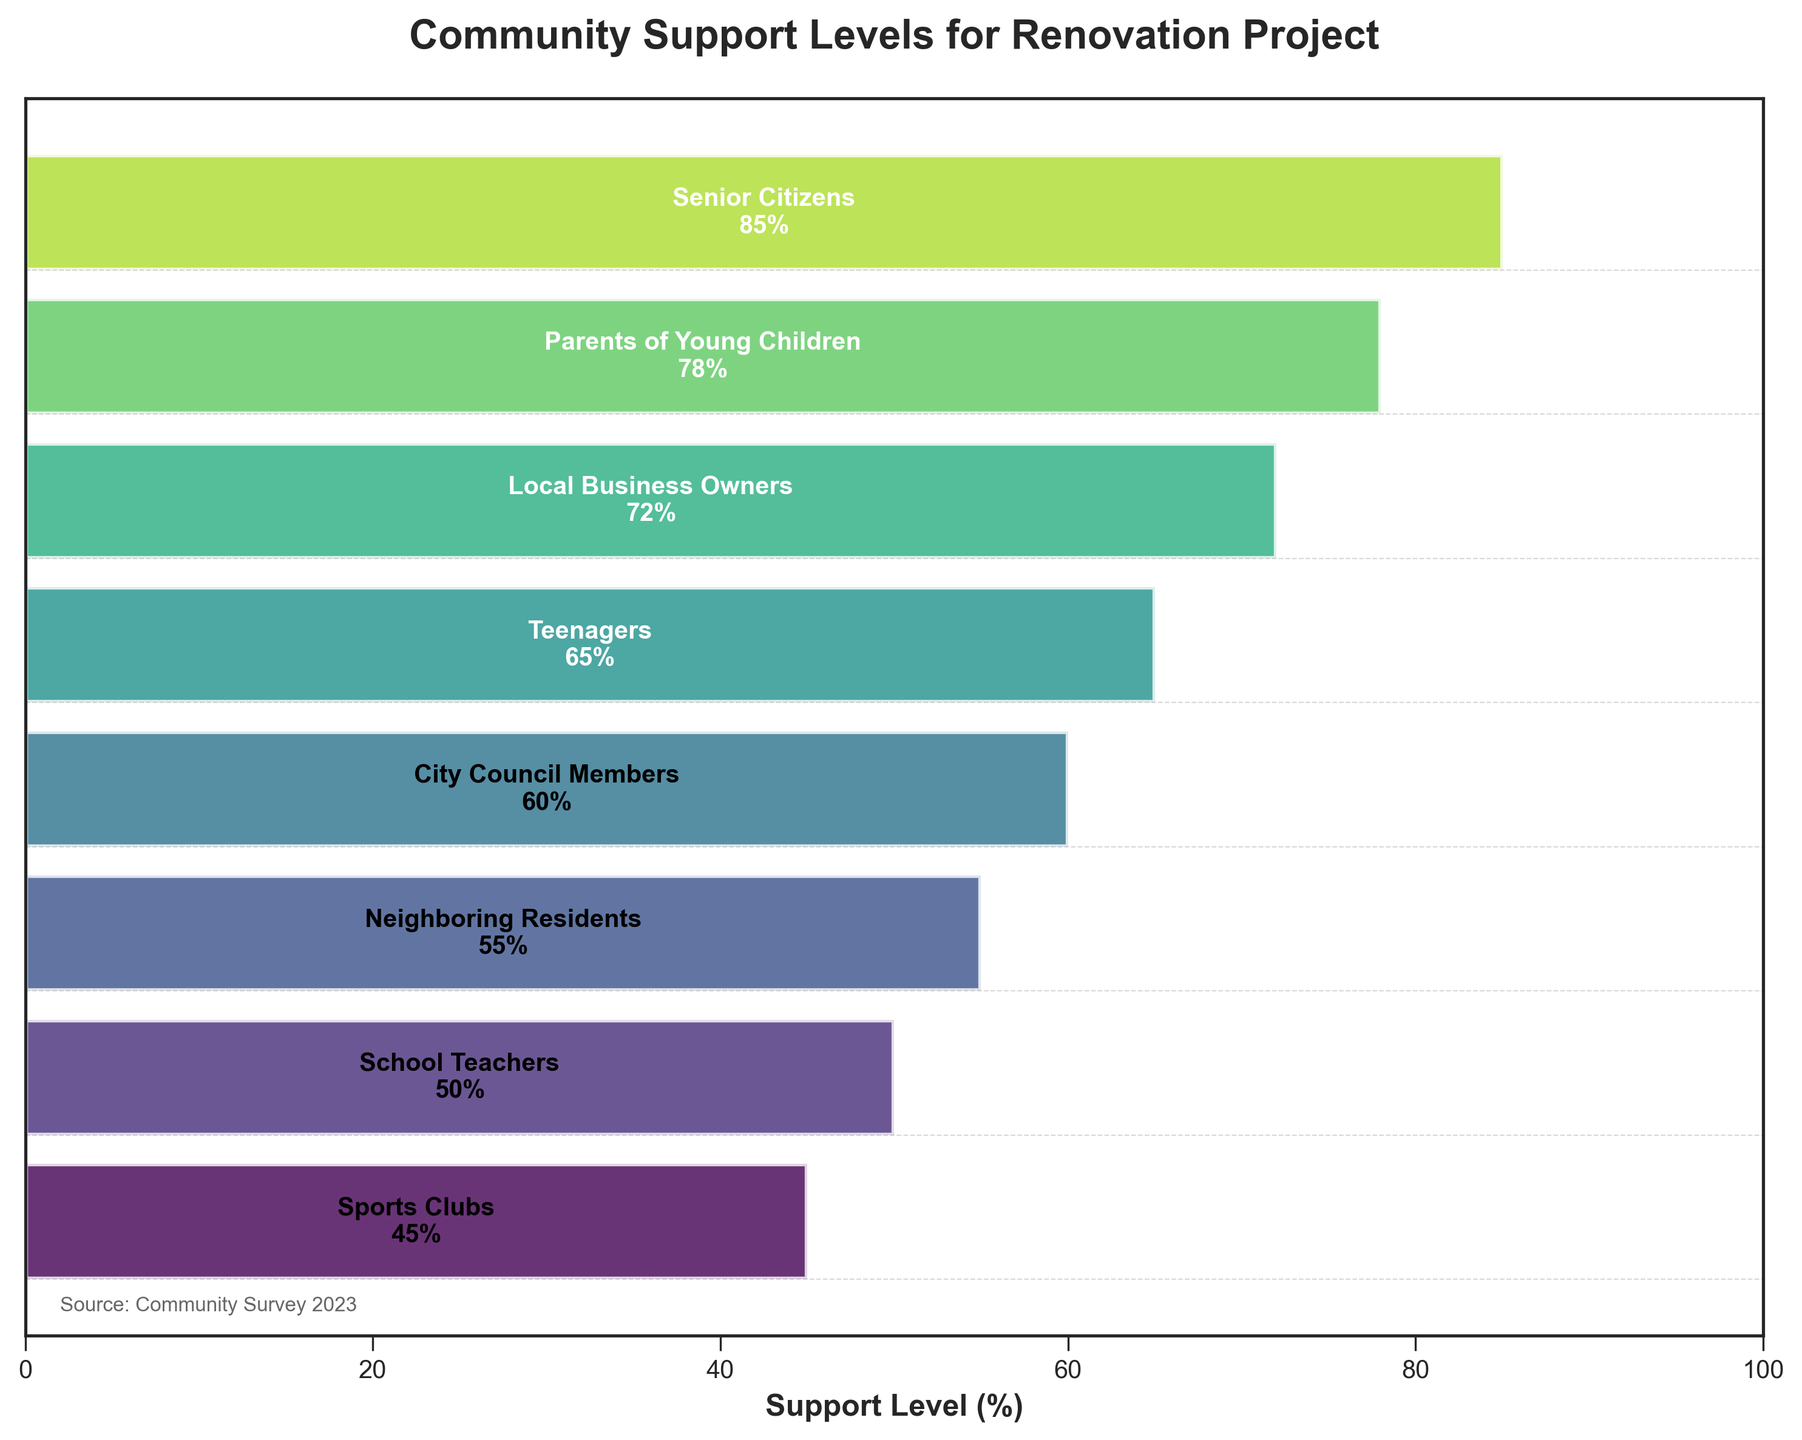What is the title of the chart? The title is usually at the top of the chart. From there, you can read the words.
Answer: Community Support Levels for Renovation Project Which stakeholder group has the highest support level? The support levels decrease from top to bottom, and the highest bar represents the highest support level.
Answer: Senior Citizens What is the support level for Teenagers? Look at the bar corresponding to Teenagers and read the support level indicated in the middle of the bar.
Answer: 65% Which stakeholder group has the lowest support level? The support levels decrease from top to bottom, and the lowest bar represents the lowest support level.
Answer: Sports Clubs By how much does the support level of Parents of Young Children exceed that of School Teachers? Find the support levels of both groups and subtract the lower support level from the higher one: 78% - 50% = 28%
Answer: 28% What is the range of support levels represented in the chart? The range is the difference between the highest and lowest support levels: 85% - 45% = 40%
Answer: 40% Which group has a support level exactly in the middle of the range (median position) among the listed stakeholders? Arrange the support levels in ascending order: [45, 50, 55, 60, 65, 72, 78, 85]. The middle two are 60 and 65, and the average is (60+65)/2 = 62.5. Hence, it's closest to City Council Members at 60 and Teenagers at 65.
Answer: City Council Members and Teenagers How does the support level of Local Business Owners compare to that of Neighboring Residents? Compare the support levels of both groups: Local Business Owners have 72%, and Neighboring Residents have 55%. So, Local Business Owners have a higher support level.
Answer: Local Business Owners have higher support than Neighboring Residents Which group falls just below the support level of Local Business Owners? Look for the next immediate lower support level below Local Business Owners (72%). The group with 65% is Teenagers.
Answer: Teenagers How much higher is the support level of Senior Citizens compared to the average support level of all groups? First, calculate the average support level: (85 + 78 + 72 + 65 + 60 + 55 + 50 + 45)/8 = 63.75%. Then, subtract the average from Senior Citizens' support level: 85% - 63.75% = 21.25%
Answer: 21.25% 